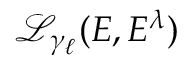Convert formula to latex. <formula><loc_0><loc_0><loc_500><loc_500>\mathcal { L } _ { \gamma _ { \ell } } ( E , E ^ { \lambda } )</formula> 